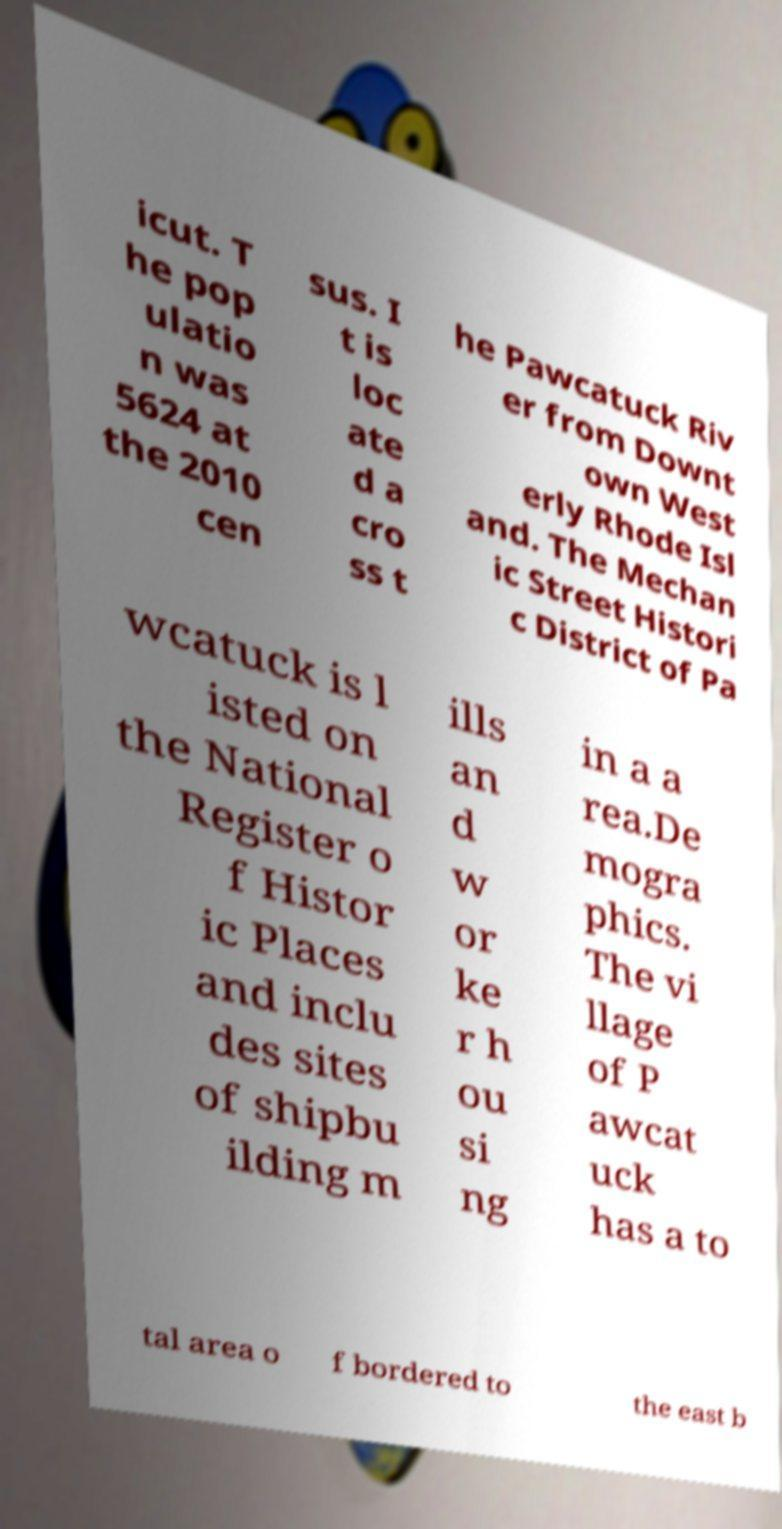Could you assist in decoding the text presented in this image and type it out clearly? icut. T he pop ulatio n was 5624 at the 2010 cen sus. I t is loc ate d a cro ss t he Pawcatuck Riv er from Downt own West erly Rhode Isl and. The Mechan ic Street Histori c District of Pa wcatuck is l isted on the National Register o f Histor ic Places and inclu des sites of shipbu ilding m ills an d w or ke r h ou si ng in a a rea.De mogra phics. The vi llage of P awcat uck has a to tal area o f bordered to the east b 